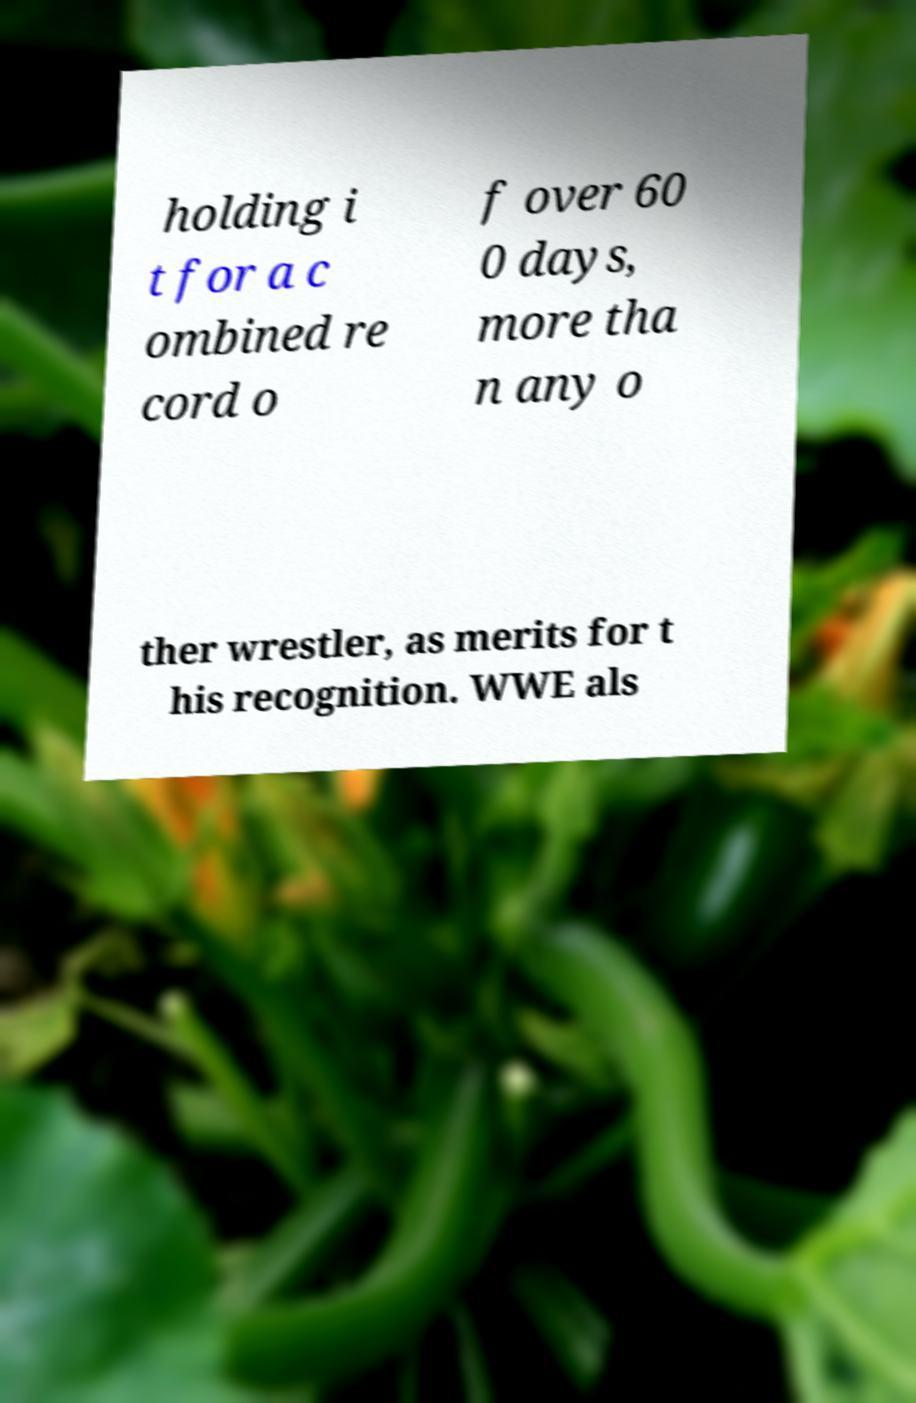There's text embedded in this image that I need extracted. Can you transcribe it verbatim? holding i t for a c ombined re cord o f over 60 0 days, more tha n any o ther wrestler, as merits for t his recognition. WWE als 